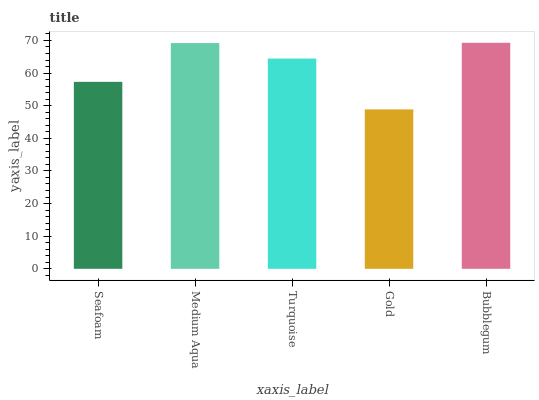Is Gold the minimum?
Answer yes or no. Yes. Is Bubblegum the maximum?
Answer yes or no. Yes. Is Medium Aqua the minimum?
Answer yes or no. No. Is Medium Aqua the maximum?
Answer yes or no. No. Is Medium Aqua greater than Seafoam?
Answer yes or no. Yes. Is Seafoam less than Medium Aqua?
Answer yes or no. Yes. Is Seafoam greater than Medium Aqua?
Answer yes or no. No. Is Medium Aqua less than Seafoam?
Answer yes or no. No. Is Turquoise the high median?
Answer yes or no. Yes. Is Turquoise the low median?
Answer yes or no. Yes. Is Bubblegum the high median?
Answer yes or no. No. Is Seafoam the low median?
Answer yes or no. No. 